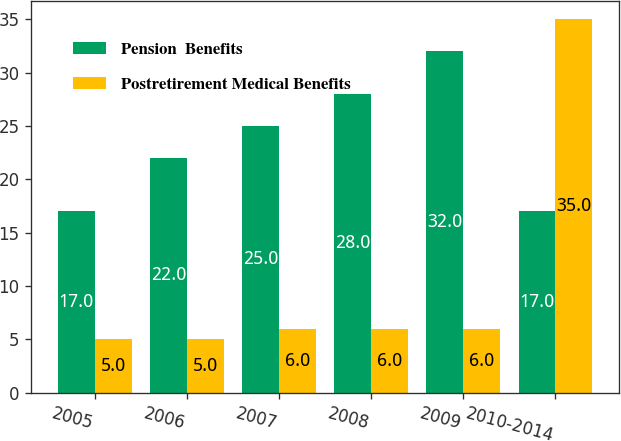Convert chart to OTSL. <chart><loc_0><loc_0><loc_500><loc_500><stacked_bar_chart><ecel><fcel>2005<fcel>2006<fcel>2007<fcel>2008<fcel>2009<fcel>2010-2014<nl><fcel>Pension  Benefits<fcel>17<fcel>22<fcel>25<fcel>28<fcel>32<fcel>17<nl><fcel>Postretirement Medical Benefits<fcel>5<fcel>5<fcel>6<fcel>6<fcel>6<fcel>35<nl></chart> 